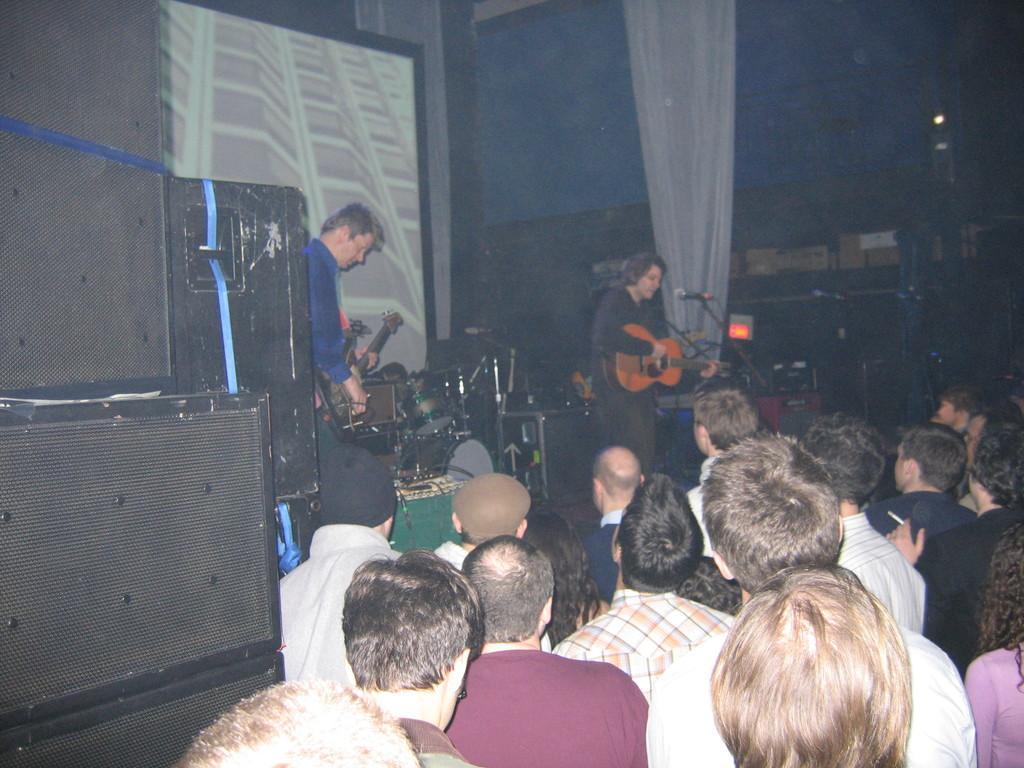Could you give a brief overview of what you see in this image? In the center of the image we can see persons holding a guitar and performing on dais. At the bottom of the image we can see crowd. On the left side of the image there are speakers. In the background there is a screen, musical equipment, curtain and wall. 